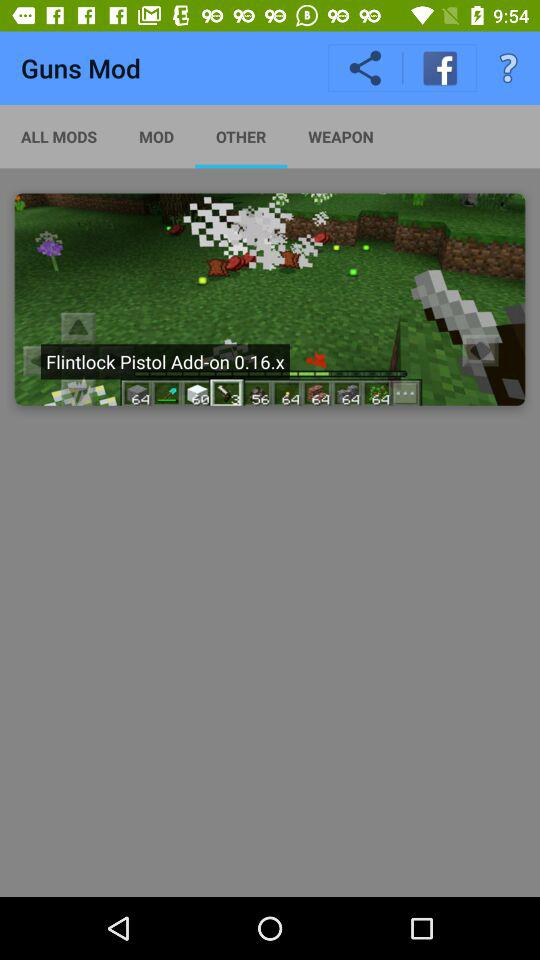Which tab is selected? The selected tab is "OTHER". 